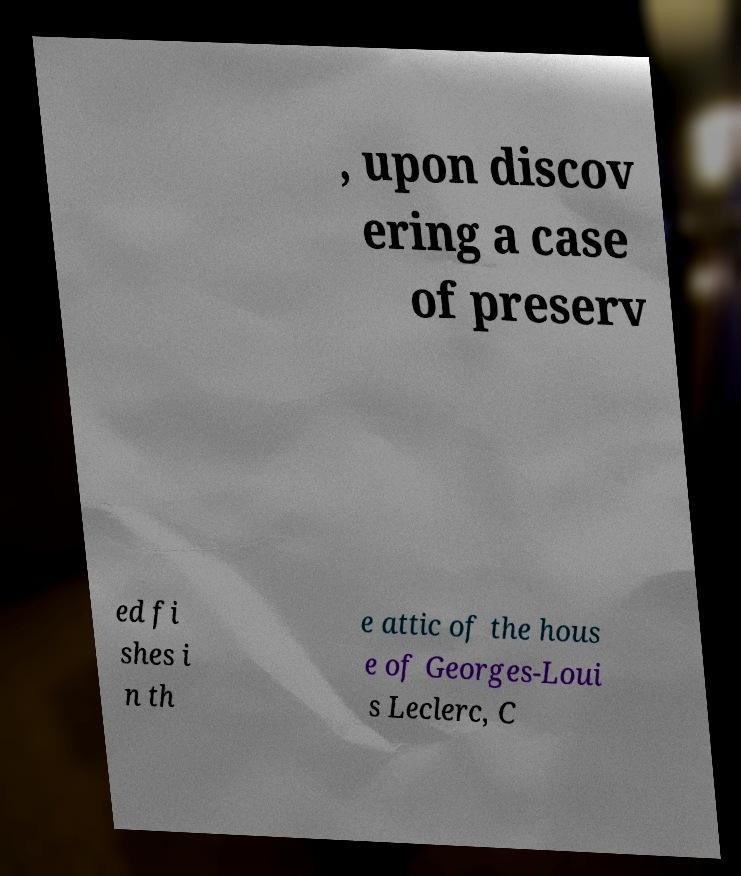Please read and relay the text visible in this image. What does it say? , upon discov ering a case of preserv ed fi shes i n th e attic of the hous e of Georges-Loui s Leclerc, C 